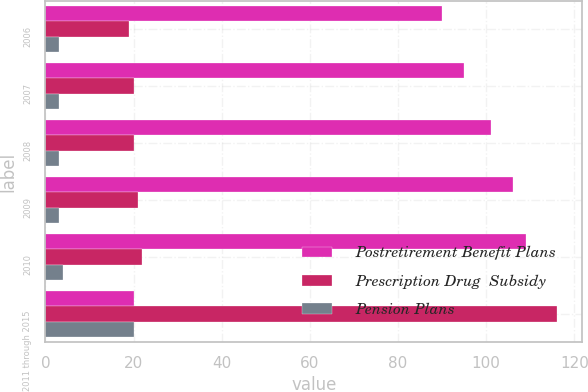<chart> <loc_0><loc_0><loc_500><loc_500><stacked_bar_chart><ecel><fcel>2006<fcel>2007<fcel>2008<fcel>2009<fcel>2010<fcel>2011 through 2015<nl><fcel>Postretirement Benefit Plans<fcel>90<fcel>95<fcel>101<fcel>106<fcel>109<fcel>20<nl><fcel>Prescription Drug  Subsidy<fcel>19<fcel>20<fcel>20<fcel>21<fcel>22<fcel>116<nl><fcel>Pension Plans<fcel>3<fcel>3<fcel>3<fcel>3<fcel>4<fcel>20<nl></chart> 